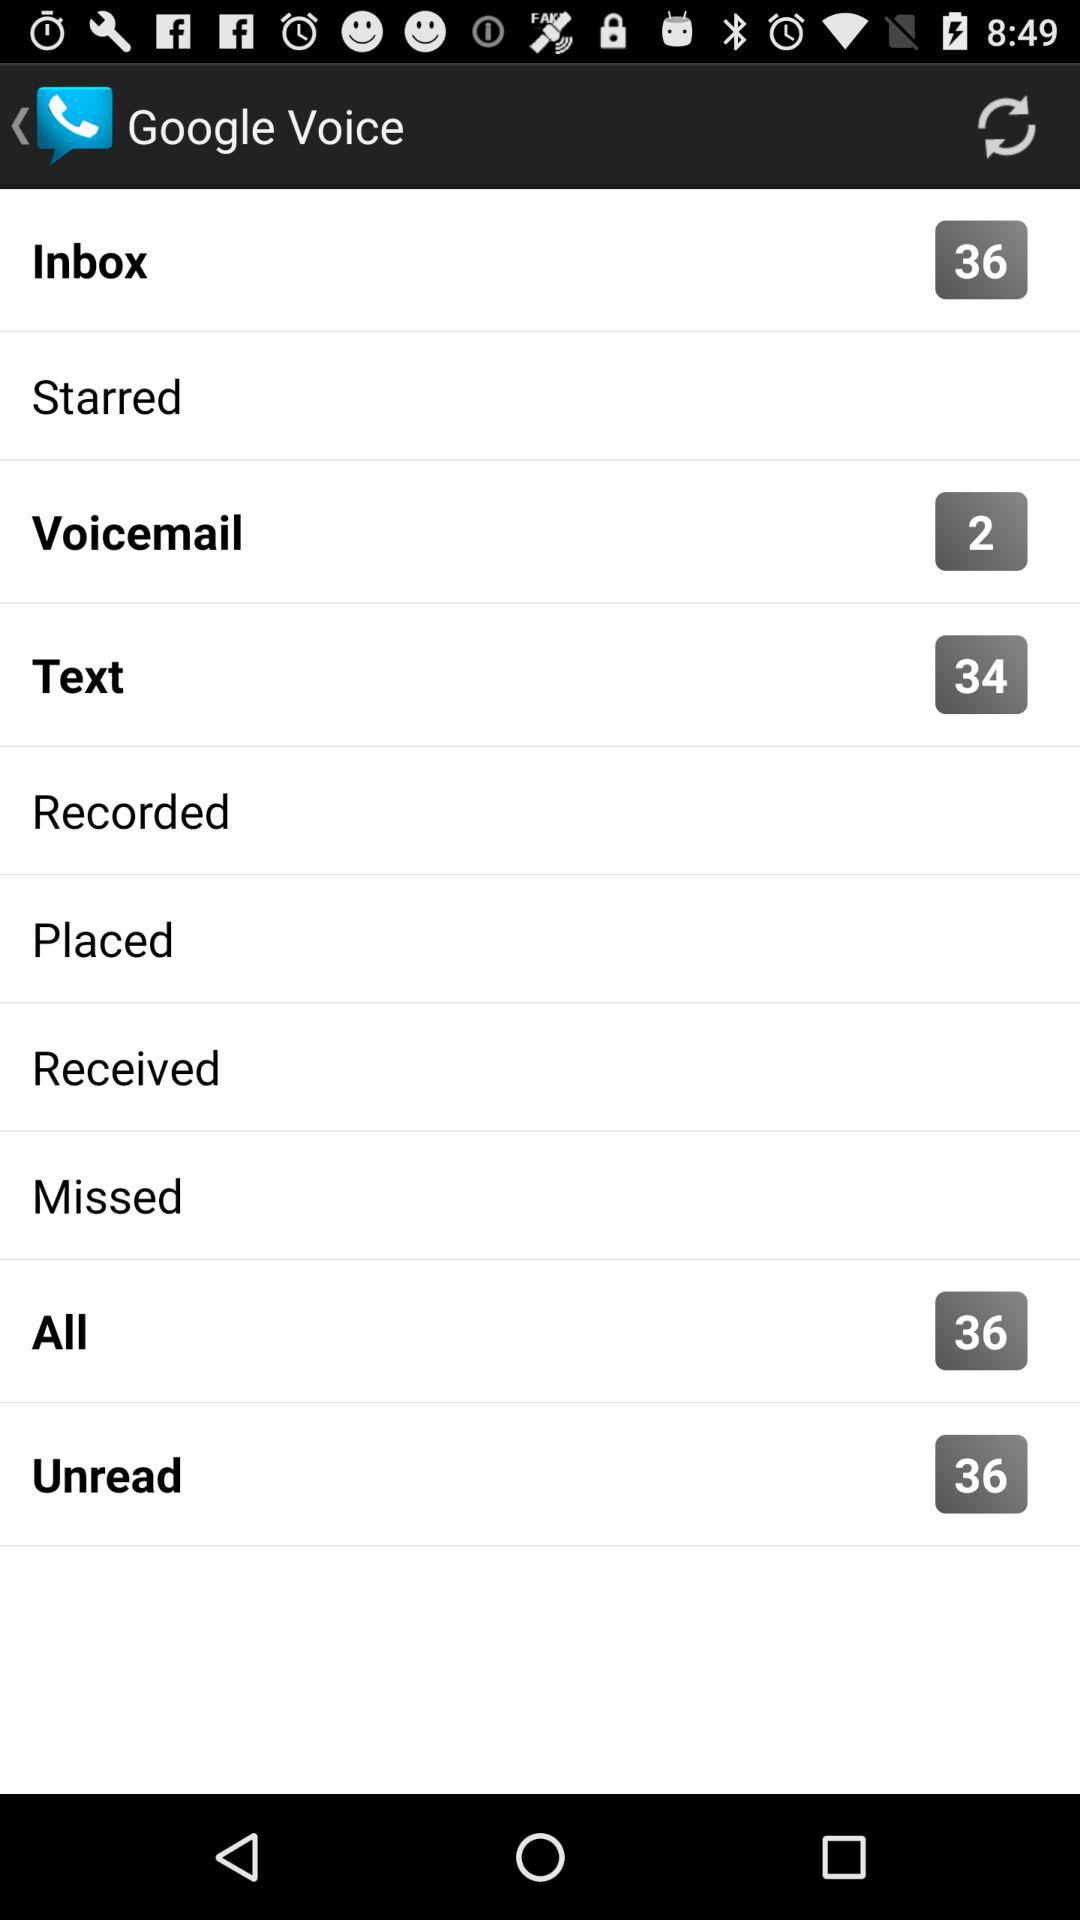How many voicemail are showing? The number of voicemails showing is 2. 